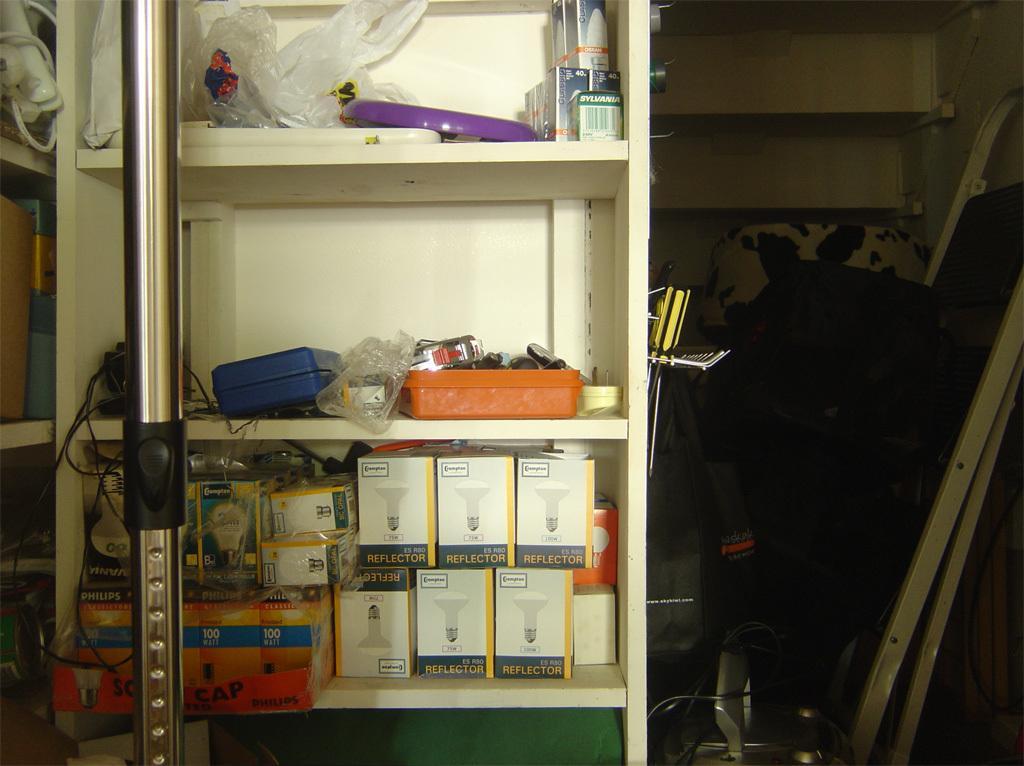Could you give a brief overview of what you see in this image? On the left side of the image we can see a rack in which some objects are kept. In the middle of the image we can see a rack in which some boxes are there and some objects are there. On the right side of the image we can see an iron rod and some objects. 